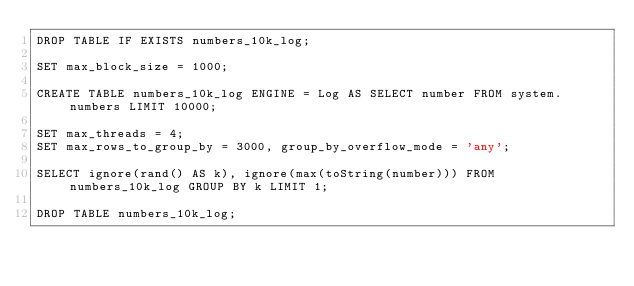<code> <loc_0><loc_0><loc_500><loc_500><_SQL_>DROP TABLE IF EXISTS numbers_10k_log;

SET max_block_size = 1000;

CREATE TABLE numbers_10k_log ENGINE = Log AS SELECT number FROM system.numbers LIMIT 10000;

SET max_threads = 4;
SET max_rows_to_group_by = 3000, group_by_overflow_mode = 'any';

SELECT ignore(rand() AS k), ignore(max(toString(number))) FROM numbers_10k_log GROUP BY k LIMIT 1;

DROP TABLE numbers_10k_log;
</code> 